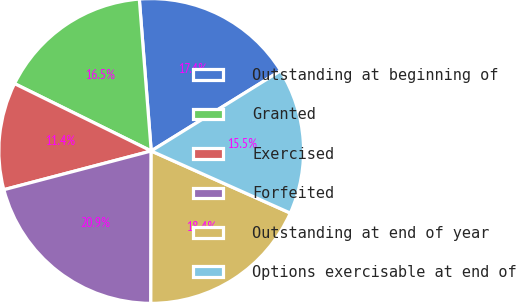<chart> <loc_0><loc_0><loc_500><loc_500><pie_chart><fcel>Outstanding at beginning of<fcel>Granted<fcel>Exercised<fcel>Forfeited<fcel>Outstanding at end of year<fcel>Options exercisable at end of<nl><fcel>17.41%<fcel>16.47%<fcel>11.38%<fcel>20.87%<fcel>18.36%<fcel>15.52%<nl></chart> 